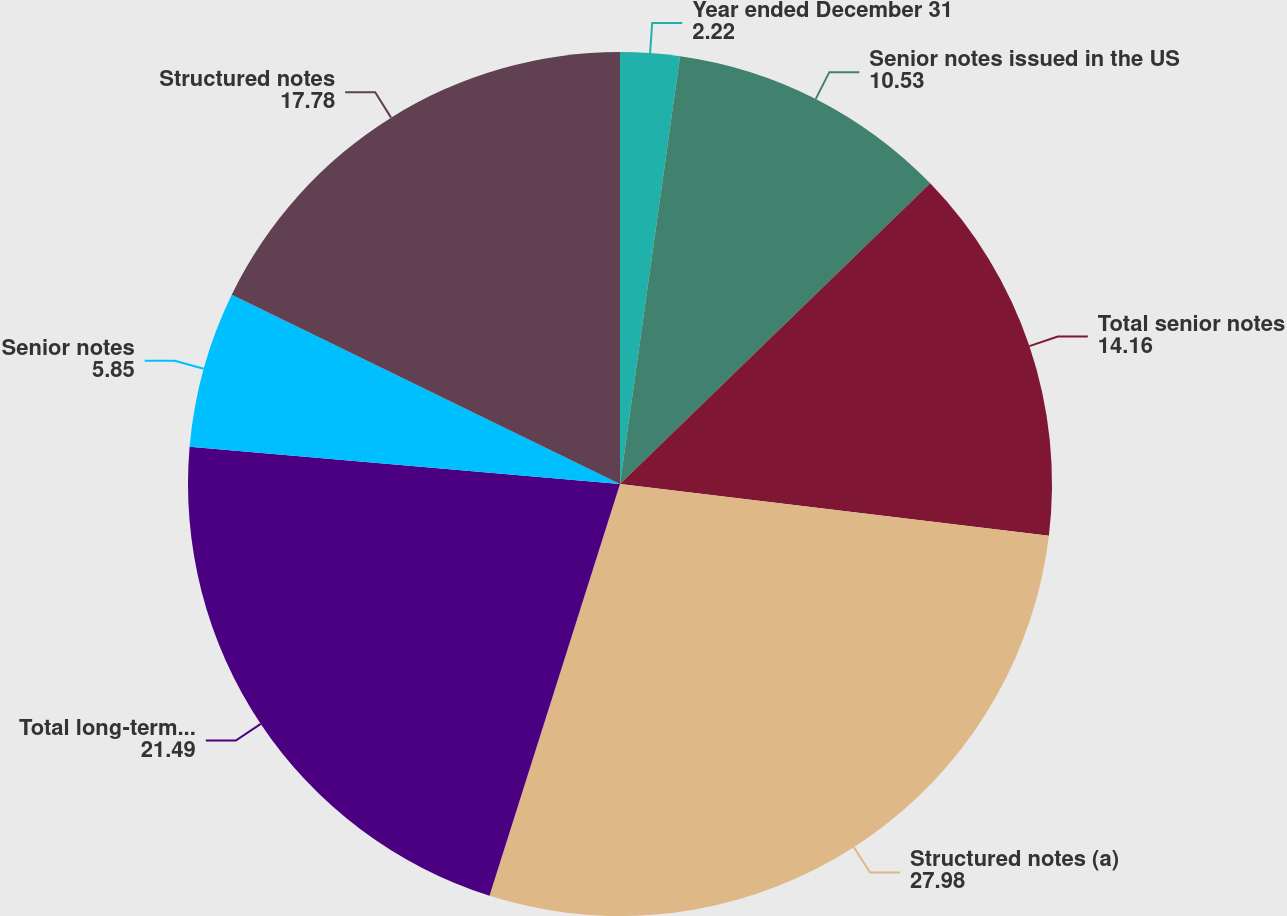Convert chart to OTSL. <chart><loc_0><loc_0><loc_500><loc_500><pie_chart><fcel>Year ended December 31<fcel>Senior notes issued in the US<fcel>Total senior notes<fcel>Structured notes (a)<fcel>Total long-term unsecured<fcel>Senior notes<fcel>Structured notes<nl><fcel>2.22%<fcel>10.53%<fcel>14.16%<fcel>27.98%<fcel>21.49%<fcel>5.85%<fcel>17.78%<nl></chart> 